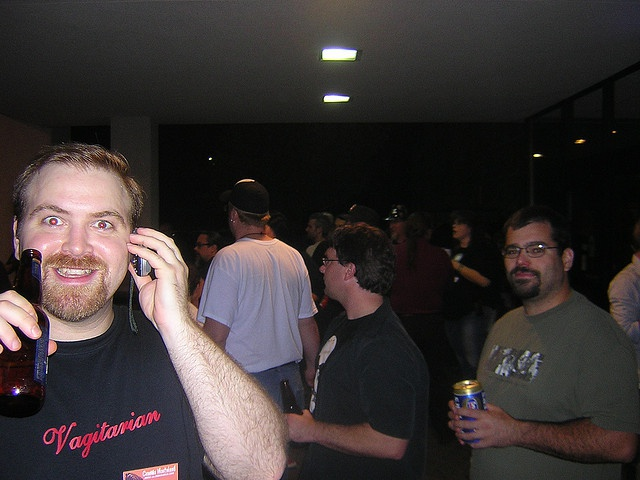Describe the objects in this image and their specific colors. I can see people in black, lightpink, lightgray, and darkgray tones, people in black, maroon, and brown tones, people in black, brown, and maroon tones, people in black and gray tones, and people in black and maroon tones in this image. 